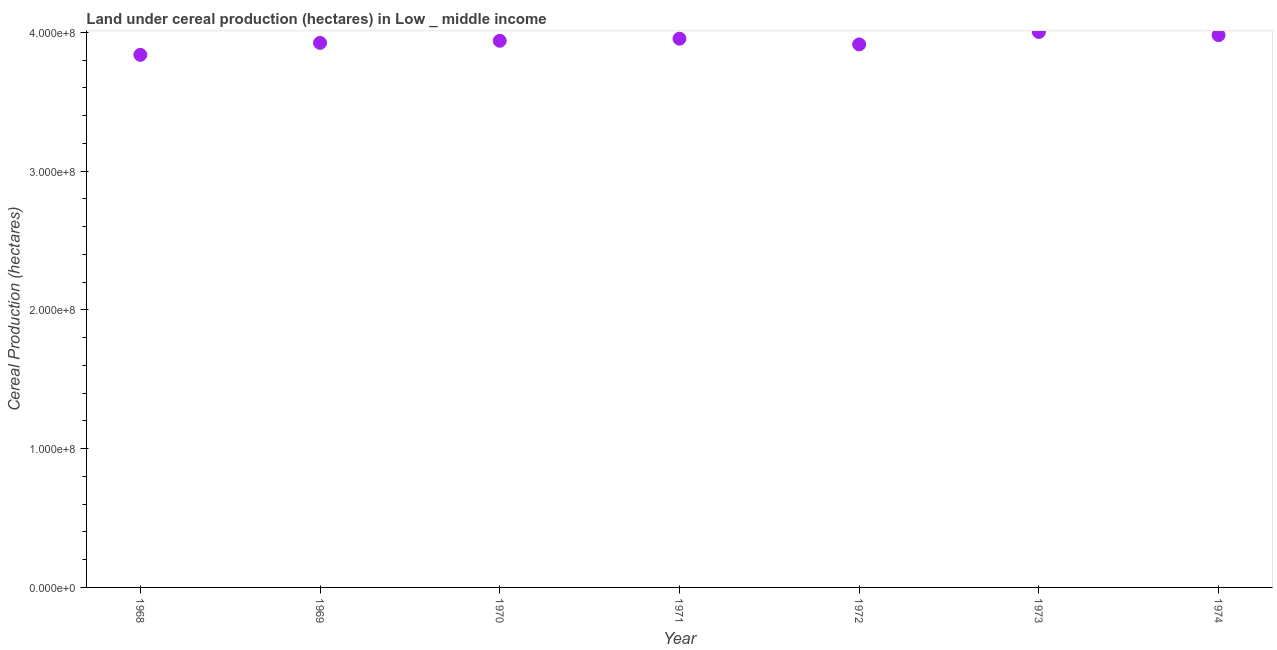What is the land under cereal production in 1973?
Ensure brevity in your answer.  4.00e+08. Across all years, what is the maximum land under cereal production?
Offer a terse response. 4.00e+08. Across all years, what is the minimum land under cereal production?
Your response must be concise. 3.84e+08. In which year was the land under cereal production minimum?
Offer a terse response. 1968. What is the sum of the land under cereal production?
Keep it short and to the point. 2.76e+09. What is the difference between the land under cereal production in 1972 and 1973?
Your response must be concise. -8.97e+06. What is the average land under cereal production per year?
Ensure brevity in your answer.  3.94e+08. What is the median land under cereal production?
Ensure brevity in your answer.  3.94e+08. In how many years, is the land under cereal production greater than 300000000 hectares?
Your answer should be compact. 7. What is the ratio of the land under cereal production in 1970 to that in 1972?
Make the answer very short. 1.01. Is the land under cereal production in 1971 less than that in 1973?
Offer a very short reply. Yes. Is the difference between the land under cereal production in 1968 and 1969 greater than the difference between any two years?
Ensure brevity in your answer.  No. What is the difference between the highest and the second highest land under cereal production?
Your answer should be very brief. 2.28e+06. What is the difference between the highest and the lowest land under cereal production?
Your response must be concise. 1.65e+07. Does the land under cereal production monotonically increase over the years?
Give a very brief answer. No. How many years are there in the graph?
Provide a succinct answer. 7. Are the values on the major ticks of Y-axis written in scientific E-notation?
Offer a very short reply. Yes. Does the graph contain any zero values?
Your response must be concise. No. Does the graph contain grids?
Provide a short and direct response. No. What is the title of the graph?
Ensure brevity in your answer.  Land under cereal production (hectares) in Low _ middle income. What is the label or title of the Y-axis?
Provide a short and direct response. Cereal Production (hectares). What is the Cereal Production (hectares) in 1968?
Provide a succinct answer. 3.84e+08. What is the Cereal Production (hectares) in 1969?
Your response must be concise. 3.92e+08. What is the Cereal Production (hectares) in 1970?
Provide a short and direct response. 3.94e+08. What is the Cereal Production (hectares) in 1971?
Your answer should be compact. 3.95e+08. What is the Cereal Production (hectares) in 1972?
Your answer should be compact. 3.91e+08. What is the Cereal Production (hectares) in 1973?
Offer a very short reply. 4.00e+08. What is the Cereal Production (hectares) in 1974?
Give a very brief answer. 3.98e+08. What is the difference between the Cereal Production (hectares) in 1968 and 1969?
Your response must be concise. -8.64e+06. What is the difference between the Cereal Production (hectares) in 1968 and 1970?
Offer a very short reply. -1.01e+07. What is the difference between the Cereal Production (hectares) in 1968 and 1971?
Offer a terse response. -1.16e+07. What is the difference between the Cereal Production (hectares) in 1968 and 1972?
Make the answer very short. -7.52e+06. What is the difference between the Cereal Production (hectares) in 1968 and 1973?
Your response must be concise. -1.65e+07. What is the difference between the Cereal Production (hectares) in 1968 and 1974?
Your answer should be compact. -1.42e+07. What is the difference between the Cereal Production (hectares) in 1969 and 1970?
Make the answer very short. -1.49e+06. What is the difference between the Cereal Production (hectares) in 1969 and 1971?
Your answer should be very brief. -3.00e+06. What is the difference between the Cereal Production (hectares) in 1969 and 1972?
Provide a short and direct response. 1.12e+06. What is the difference between the Cereal Production (hectares) in 1969 and 1973?
Offer a very short reply. -7.85e+06. What is the difference between the Cereal Production (hectares) in 1969 and 1974?
Your answer should be very brief. -5.57e+06. What is the difference between the Cereal Production (hectares) in 1970 and 1971?
Provide a succinct answer. -1.50e+06. What is the difference between the Cereal Production (hectares) in 1970 and 1972?
Your answer should be compact. 2.61e+06. What is the difference between the Cereal Production (hectares) in 1970 and 1973?
Make the answer very short. -6.35e+06. What is the difference between the Cereal Production (hectares) in 1970 and 1974?
Your answer should be compact. -4.07e+06. What is the difference between the Cereal Production (hectares) in 1971 and 1972?
Offer a very short reply. 4.12e+06. What is the difference between the Cereal Production (hectares) in 1971 and 1973?
Keep it short and to the point. -4.85e+06. What is the difference between the Cereal Production (hectares) in 1971 and 1974?
Your answer should be compact. -2.57e+06. What is the difference between the Cereal Production (hectares) in 1972 and 1973?
Ensure brevity in your answer.  -8.97e+06. What is the difference between the Cereal Production (hectares) in 1972 and 1974?
Keep it short and to the point. -6.69e+06. What is the difference between the Cereal Production (hectares) in 1973 and 1974?
Provide a succinct answer. 2.28e+06. What is the ratio of the Cereal Production (hectares) in 1968 to that in 1970?
Keep it short and to the point. 0.97. What is the ratio of the Cereal Production (hectares) in 1968 to that in 1971?
Your answer should be very brief. 0.97. What is the ratio of the Cereal Production (hectares) in 1968 to that in 1973?
Give a very brief answer. 0.96. What is the ratio of the Cereal Production (hectares) in 1968 to that in 1974?
Your answer should be very brief. 0.96. What is the ratio of the Cereal Production (hectares) in 1969 to that in 1970?
Provide a succinct answer. 1. What is the ratio of the Cereal Production (hectares) in 1969 to that in 1973?
Your answer should be very brief. 0.98. What is the ratio of the Cereal Production (hectares) in 1970 to that in 1973?
Your answer should be very brief. 0.98. What is the ratio of the Cereal Production (hectares) in 1972 to that in 1974?
Offer a very short reply. 0.98. 